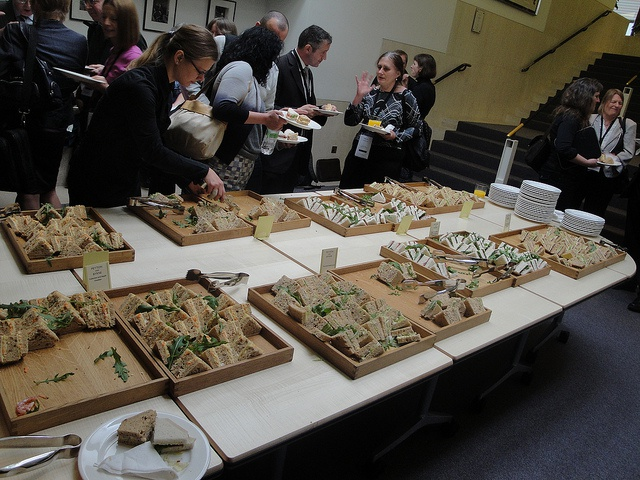Describe the objects in this image and their specific colors. I can see dining table in gray, darkgray, and black tones, sandwich in gray and black tones, dining table in gray, darkgray, and tan tones, people in gray, black, and maroon tones, and people in gray and black tones in this image. 